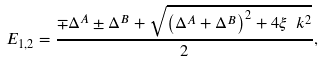Convert formula to latex. <formula><loc_0><loc_0><loc_500><loc_500>E _ { 1 , 2 } = \frac { \mp \Delta ^ { A } \pm \Delta ^ { B } + \sqrt { \left ( \Delta ^ { A } + \Delta ^ { B } \right ) ^ { 2 } + 4 \xi _ { \ } k ^ { 2 } } } { 2 } ,</formula> 